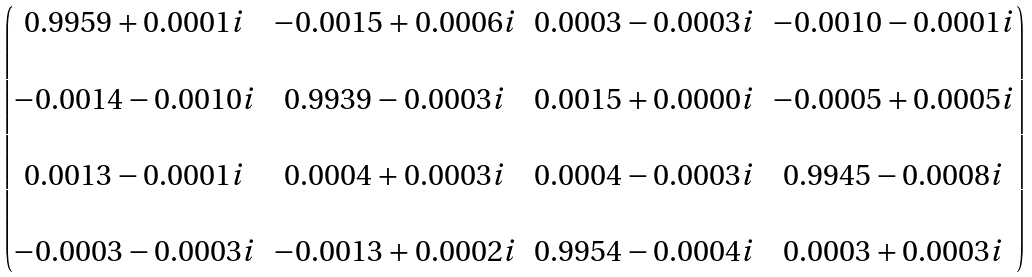<formula> <loc_0><loc_0><loc_500><loc_500>\begin{pmatrix} 0 . 9 9 5 9 + 0 . 0 0 0 1 i & - 0 . 0 0 1 5 + 0 . 0 0 0 6 i & 0 . 0 0 0 3 - 0 . 0 0 0 3 i & - 0 . 0 0 1 0 - 0 . 0 0 0 1 i \\ \\ - 0 . 0 0 1 4 - 0 . 0 0 1 0 i & 0 . 9 9 3 9 - 0 . 0 0 0 3 i & 0 . 0 0 1 5 + 0 . 0 0 0 0 i & - 0 . 0 0 0 5 + 0 . 0 0 0 5 i \\ \\ 0 . 0 0 1 3 - 0 . 0 0 0 1 i & 0 . 0 0 0 4 + 0 . 0 0 0 3 i & 0 . 0 0 0 4 - 0 . 0 0 0 3 i & 0 . 9 9 4 5 - 0 . 0 0 0 8 i \\ \\ - 0 . 0 0 0 3 - 0 . 0 0 0 3 i & - 0 . 0 0 1 3 + 0 . 0 0 0 2 i & 0 . 9 9 5 4 - 0 . 0 0 0 4 i & 0 . 0 0 0 3 + 0 . 0 0 0 3 i \end{pmatrix}</formula> 